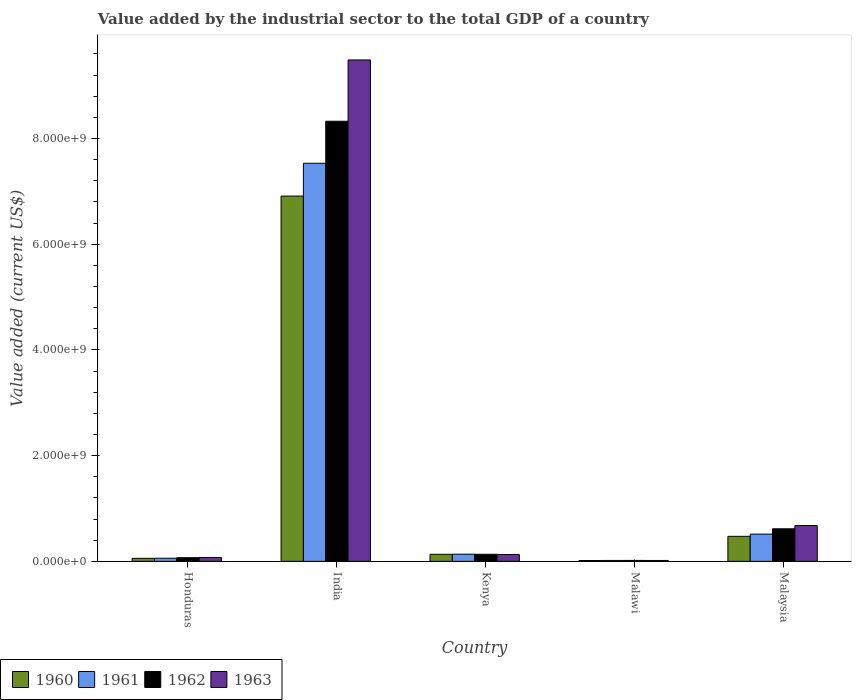How many groups of bars are there?
Offer a terse response. 5. Are the number of bars on each tick of the X-axis equal?
Your answer should be compact. Yes. How many bars are there on the 5th tick from the left?
Keep it short and to the point. 4. How many bars are there on the 5th tick from the right?
Give a very brief answer. 4. What is the value added by the industrial sector to the total GDP in 1963 in Honduras?
Offer a very short reply. 7.38e+07. Across all countries, what is the maximum value added by the industrial sector to the total GDP in 1962?
Your response must be concise. 8.33e+09. Across all countries, what is the minimum value added by the industrial sector to the total GDP in 1960?
Ensure brevity in your answer.  1.62e+07. In which country was the value added by the industrial sector to the total GDP in 1962 maximum?
Your response must be concise. India. In which country was the value added by the industrial sector to the total GDP in 1961 minimum?
Give a very brief answer. Malawi. What is the total value added by the industrial sector to the total GDP in 1961 in the graph?
Offer a terse response. 8.26e+09. What is the difference between the value added by the industrial sector to the total GDP in 1962 in Honduras and that in India?
Give a very brief answer. -8.26e+09. What is the difference between the value added by the industrial sector to the total GDP in 1963 in India and the value added by the industrial sector to the total GDP in 1962 in Malawi?
Your answer should be compact. 9.47e+09. What is the average value added by the industrial sector to the total GDP in 1960 per country?
Provide a short and direct response. 1.52e+09. What is the difference between the value added by the industrial sector to the total GDP of/in 1962 and value added by the industrial sector to the total GDP of/in 1963 in Malawi?
Your response must be concise. 8.40e+05. What is the ratio of the value added by the industrial sector to the total GDP in 1960 in Honduras to that in Kenya?
Provide a short and direct response. 0.43. Is the value added by the industrial sector to the total GDP in 1963 in India less than that in Malawi?
Your answer should be very brief. No. Is the difference between the value added by the industrial sector to the total GDP in 1962 in Honduras and Malaysia greater than the difference between the value added by the industrial sector to the total GDP in 1963 in Honduras and Malaysia?
Offer a very short reply. Yes. What is the difference between the highest and the second highest value added by the industrial sector to the total GDP in 1963?
Your answer should be very brief. 9.36e+09. What is the difference between the highest and the lowest value added by the industrial sector to the total GDP in 1962?
Give a very brief answer. 8.31e+09. Is the sum of the value added by the industrial sector to the total GDP in 1960 in India and Malawi greater than the maximum value added by the industrial sector to the total GDP in 1963 across all countries?
Give a very brief answer. No. How many countries are there in the graph?
Provide a succinct answer. 5. What is the difference between two consecutive major ticks on the Y-axis?
Your response must be concise. 2.00e+09. Does the graph contain any zero values?
Offer a very short reply. No. Where does the legend appear in the graph?
Give a very brief answer. Bottom left. How many legend labels are there?
Provide a short and direct response. 4. What is the title of the graph?
Ensure brevity in your answer.  Value added by the industrial sector to the total GDP of a country. What is the label or title of the X-axis?
Your response must be concise. Country. What is the label or title of the Y-axis?
Give a very brief answer. Value added (current US$). What is the Value added (current US$) of 1960 in Honduras?
Your response must be concise. 5.73e+07. What is the Value added (current US$) of 1961 in Honduras?
Keep it short and to the point. 5.94e+07. What is the Value added (current US$) in 1962 in Honduras?
Your answer should be compact. 6.92e+07. What is the Value added (current US$) in 1963 in Honduras?
Keep it short and to the point. 7.38e+07. What is the Value added (current US$) of 1960 in India?
Make the answer very short. 6.91e+09. What is the Value added (current US$) of 1961 in India?
Give a very brief answer. 7.53e+09. What is the Value added (current US$) in 1962 in India?
Ensure brevity in your answer.  8.33e+09. What is the Value added (current US$) of 1963 in India?
Keep it short and to the point. 9.49e+09. What is the Value added (current US$) of 1960 in Kenya?
Your answer should be very brief. 1.34e+08. What is the Value added (current US$) of 1961 in Kenya?
Your answer should be very brief. 1.36e+08. What is the Value added (current US$) in 1962 in Kenya?
Keep it short and to the point. 1.34e+08. What is the Value added (current US$) of 1963 in Kenya?
Keep it short and to the point. 1.30e+08. What is the Value added (current US$) of 1960 in Malawi?
Offer a very short reply. 1.62e+07. What is the Value added (current US$) in 1961 in Malawi?
Your answer should be very brief. 1.76e+07. What is the Value added (current US$) in 1962 in Malawi?
Make the answer very short. 1.78e+07. What is the Value added (current US$) in 1963 in Malawi?
Your answer should be very brief. 1.69e+07. What is the Value added (current US$) in 1960 in Malaysia?
Your answer should be very brief. 4.74e+08. What is the Value added (current US$) in 1961 in Malaysia?
Your answer should be compact. 5.15e+08. What is the Value added (current US$) of 1962 in Malaysia?
Your answer should be compact. 6.16e+08. What is the Value added (current US$) of 1963 in Malaysia?
Provide a succinct answer. 6.77e+08. Across all countries, what is the maximum Value added (current US$) of 1960?
Offer a terse response. 6.91e+09. Across all countries, what is the maximum Value added (current US$) in 1961?
Give a very brief answer. 7.53e+09. Across all countries, what is the maximum Value added (current US$) of 1962?
Offer a terse response. 8.33e+09. Across all countries, what is the maximum Value added (current US$) in 1963?
Give a very brief answer. 9.49e+09. Across all countries, what is the minimum Value added (current US$) of 1960?
Offer a very short reply. 1.62e+07. Across all countries, what is the minimum Value added (current US$) of 1961?
Your answer should be compact. 1.76e+07. Across all countries, what is the minimum Value added (current US$) of 1962?
Keep it short and to the point. 1.78e+07. Across all countries, what is the minimum Value added (current US$) of 1963?
Offer a very short reply. 1.69e+07. What is the total Value added (current US$) of 1960 in the graph?
Provide a short and direct response. 7.59e+09. What is the total Value added (current US$) in 1961 in the graph?
Your response must be concise. 8.26e+09. What is the total Value added (current US$) in 1962 in the graph?
Ensure brevity in your answer.  9.16e+09. What is the total Value added (current US$) of 1963 in the graph?
Give a very brief answer. 1.04e+1. What is the difference between the Value added (current US$) of 1960 in Honduras and that in India?
Your answer should be very brief. -6.85e+09. What is the difference between the Value added (current US$) of 1961 in Honduras and that in India?
Offer a terse response. -7.47e+09. What is the difference between the Value added (current US$) of 1962 in Honduras and that in India?
Offer a terse response. -8.26e+09. What is the difference between the Value added (current US$) in 1963 in Honduras and that in India?
Keep it short and to the point. -9.41e+09. What is the difference between the Value added (current US$) of 1960 in Honduras and that in Kenya?
Offer a terse response. -7.63e+07. What is the difference between the Value added (current US$) of 1961 in Honduras and that in Kenya?
Offer a very short reply. -7.65e+07. What is the difference between the Value added (current US$) of 1962 in Honduras and that in Kenya?
Your answer should be very brief. -6.47e+07. What is the difference between the Value added (current US$) in 1963 in Honduras and that in Kenya?
Offer a terse response. -5.57e+07. What is the difference between the Value added (current US$) in 1960 in Honduras and that in Malawi?
Give a very brief answer. 4.11e+07. What is the difference between the Value added (current US$) in 1961 in Honduras and that in Malawi?
Your answer should be compact. 4.17e+07. What is the difference between the Value added (current US$) in 1962 in Honduras and that in Malawi?
Offer a very short reply. 5.14e+07. What is the difference between the Value added (current US$) in 1963 in Honduras and that in Malawi?
Give a very brief answer. 5.69e+07. What is the difference between the Value added (current US$) of 1960 in Honduras and that in Malaysia?
Provide a succinct answer. -4.16e+08. What is the difference between the Value added (current US$) of 1961 in Honduras and that in Malaysia?
Your answer should be compact. -4.56e+08. What is the difference between the Value added (current US$) of 1962 in Honduras and that in Malaysia?
Offer a terse response. -5.47e+08. What is the difference between the Value added (current US$) of 1963 in Honduras and that in Malaysia?
Make the answer very short. -6.04e+08. What is the difference between the Value added (current US$) in 1960 in India and that in Kenya?
Your answer should be very brief. 6.78e+09. What is the difference between the Value added (current US$) of 1961 in India and that in Kenya?
Give a very brief answer. 7.40e+09. What is the difference between the Value added (current US$) in 1962 in India and that in Kenya?
Offer a very short reply. 8.19e+09. What is the difference between the Value added (current US$) of 1963 in India and that in Kenya?
Your response must be concise. 9.36e+09. What is the difference between the Value added (current US$) in 1960 in India and that in Malawi?
Make the answer very short. 6.89e+09. What is the difference between the Value added (current US$) in 1961 in India and that in Malawi?
Keep it short and to the point. 7.51e+09. What is the difference between the Value added (current US$) in 1962 in India and that in Malawi?
Provide a short and direct response. 8.31e+09. What is the difference between the Value added (current US$) of 1963 in India and that in Malawi?
Provide a succinct answer. 9.47e+09. What is the difference between the Value added (current US$) of 1960 in India and that in Malaysia?
Keep it short and to the point. 6.44e+09. What is the difference between the Value added (current US$) of 1961 in India and that in Malaysia?
Offer a very short reply. 7.02e+09. What is the difference between the Value added (current US$) in 1962 in India and that in Malaysia?
Your answer should be compact. 7.71e+09. What is the difference between the Value added (current US$) of 1963 in India and that in Malaysia?
Make the answer very short. 8.81e+09. What is the difference between the Value added (current US$) in 1960 in Kenya and that in Malawi?
Keep it short and to the point. 1.17e+08. What is the difference between the Value added (current US$) in 1961 in Kenya and that in Malawi?
Keep it short and to the point. 1.18e+08. What is the difference between the Value added (current US$) of 1962 in Kenya and that in Malawi?
Provide a succinct answer. 1.16e+08. What is the difference between the Value added (current US$) of 1963 in Kenya and that in Malawi?
Your response must be concise. 1.13e+08. What is the difference between the Value added (current US$) in 1960 in Kenya and that in Malaysia?
Your answer should be very brief. -3.40e+08. What is the difference between the Value added (current US$) of 1961 in Kenya and that in Malaysia?
Your response must be concise. -3.79e+08. What is the difference between the Value added (current US$) in 1962 in Kenya and that in Malaysia?
Offer a terse response. -4.82e+08. What is the difference between the Value added (current US$) in 1963 in Kenya and that in Malaysia?
Offer a very short reply. -5.48e+08. What is the difference between the Value added (current US$) in 1960 in Malawi and that in Malaysia?
Your response must be concise. -4.57e+08. What is the difference between the Value added (current US$) in 1961 in Malawi and that in Malaysia?
Your response must be concise. -4.98e+08. What is the difference between the Value added (current US$) of 1962 in Malawi and that in Malaysia?
Your response must be concise. -5.98e+08. What is the difference between the Value added (current US$) of 1963 in Malawi and that in Malaysia?
Your answer should be very brief. -6.61e+08. What is the difference between the Value added (current US$) in 1960 in Honduras and the Value added (current US$) in 1961 in India?
Offer a terse response. -7.47e+09. What is the difference between the Value added (current US$) in 1960 in Honduras and the Value added (current US$) in 1962 in India?
Ensure brevity in your answer.  -8.27e+09. What is the difference between the Value added (current US$) in 1960 in Honduras and the Value added (current US$) in 1963 in India?
Your response must be concise. -9.43e+09. What is the difference between the Value added (current US$) in 1961 in Honduras and the Value added (current US$) in 1962 in India?
Keep it short and to the point. -8.27e+09. What is the difference between the Value added (current US$) in 1961 in Honduras and the Value added (current US$) in 1963 in India?
Your answer should be compact. -9.43e+09. What is the difference between the Value added (current US$) of 1962 in Honduras and the Value added (current US$) of 1963 in India?
Provide a short and direct response. -9.42e+09. What is the difference between the Value added (current US$) of 1960 in Honduras and the Value added (current US$) of 1961 in Kenya?
Provide a short and direct response. -7.86e+07. What is the difference between the Value added (current US$) in 1960 in Honduras and the Value added (current US$) in 1962 in Kenya?
Provide a short and direct response. -7.66e+07. What is the difference between the Value added (current US$) in 1960 in Honduras and the Value added (current US$) in 1963 in Kenya?
Your response must be concise. -7.22e+07. What is the difference between the Value added (current US$) of 1961 in Honduras and the Value added (current US$) of 1962 in Kenya?
Offer a terse response. -7.46e+07. What is the difference between the Value added (current US$) in 1961 in Honduras and the Value added (current US$) in 1963 in Kenya?
Your response must be concise. -7.02e+07. What is the difference between the Value added (current US$) in 1962 in Honduras and the Value added (current US$) in 1963 in Kenya?
Offer a very short reply. -6.03e+07. What is the difference between the Value added (current US$) of 1960 in Honduras and the Value added (current US$) of 1961 in Malawi?
Ensure brevity in your answer.  3.97e+07. What is the difference between the Value added (current US$) in 1960 in Honduras and the Value added (current US$) in 1962 in Malawi?
Provide a short and direct response. 3.95e+07. What is the difference between the Value added (current US$) in 1960 in Honduras and the Value added (current US$) in 1963 in Malawi?
Your answer should be very brief. 4.04e+07. What is the difference between the Value added (current US$) in 1961 in Honduras and the Value added (current US$) in 1962 in Malawi?
Offer a terse response. 4.16e+07. What is the difference between the Value added (current US$) of 1961 in Honduras and the Value added (current US$) of 1963 in Malawi?
Your answer should be compact. 4.24e+07. What is the difference between the Value added (current US$) in 1962 in Honduras and the Value added (current US$) in 1963 in Malawi?
Your response must be concise. 5.23e+07. What is the difference between the Value added (current US$) of 1960 in Honduras and the Value added (current US$) of 1961 in Malaysia?
Ensure brevity in your answer.  -4.58e+08. What is the difference between the Value added (current US$) in 1960 in Honduras and the Value added (current US$) in 1962 in Malaysia?
Your response must be concise. -5.59e+08. What is the difference between the Value added (current US$) of 1960 in Honduras and the Value added (current US$) of 1963 in Malaysia?
Provide a short and direct response. -6.20e+08. What is the difference between the Value added (current US$) in 1961 in Honduras and the Value added (current US$) in 1962 in Malaysia?
Ensure brevity in your answer.  -5.57e+08. What is the difference between the Value added (current US$) in 1961 in Honduras and the Value added (current US$) in 1963 in Malaysia?
Offer a terse response. -6.18e+08. What is the difference between the Value added (current US$) in 1962 in Honduras and the Value added (current US$) in 1963 in Malaysia?
Give a very brief answer. -6.08e+08. What is the difference between the Value added (current US$) of 1960 in India and the Value added (current US$) of 1961 in Kenya?
Provide a short and direct response. 6.77e+09. What is the difference between the Value added (current US$) of 1960 in India and the Value added (current US$) of 1962 in Kenya?
Provide a short and direct response. 6.78e+09. What is the difference between the Value added (current US$) of 1960 in India and the Value added (current US$) of 1963 in Kenya?
Keep it short and to the point. 6.78e+09. What is the difference between the Value added (current US$) in 1961 in India and the Value added (current US$) in 1962 in Kenya?
Your response must be concise. 7.40e+09. What is the difference between the Value added (current US$) of 1961 in India and the Value added (current US$) of 1963 in Kenya?
Keep it short and to the point. 7.40e+09. What is the difference between the Value added (current US$) in 1962 in India and the Value added (current US$) in 1963 in Kenya?
Make the answer very short. 8.20e+09. What is the difference between the Value added (current US$) in 1960 in India and the Value added (current US$) in 1961 in Malawi?
Make the answer very short. 6.89e+09. What is the difference between the Value added (current US$) of 1960 in India and the Value added (current US$) of 1962 in Malawi?
Provide a succinct answer. 6.89e+09. What is the difference between the Value added (current US$) in 1960 in India and the Value added (current US$) in 1963 in Malawi?
Give a very brief answer. 6.89e+09. What is the difference between the Value added (current US$) in 1961 in India and the Value added (current US$) in 1962 in Malawi?
Offer a very short reply. 7.51e+09. What is the difference between the Value added (current US$) of 1961 in India and the Value added (current US$) of 1963 in Malawi?
Your response must be concise. 7.51e+09. What is the difference between the Value added (current US$) of 1962 in India and the Value added (current US$) of 1963 in Malawi?
Keep it short and to the point. 8.31e+09. What is the difference between the Value added (current US$) of 1960 in India and the Value added (current US$) of 1961 in Malaysia?
Provide a succinct answer. 6.39e+09. What is the difference between the Value added (current US$) in 1960 in India and the Value added (current US$) in 1962 in Malaysia?
Offer a very short reply. 6.29e+09. What is the difference between the Value added (current US$) of 1960 in India and the Value added (current US$) of 1963 in Malaysia?
Offer a very short reply. 6.23e+09. What is the difference between the Value added (current US$) of 1961 in India and the Value added (current US$) of 1962 in Malaysia?
Ensure brevity in your answer.  6.92e+09. What is the difference between the Value added (current US$) in 1961 in India and the Value added (current US$) in 1963 in Malaysia?
Keep it short and to the point. 6.85e+09. What is the difference between the Value added (current US$) of 1962 in India and the Value added (current US$) of 1963 in Malaysia?
Provide a succinct answer. 7.65e+09. What is the difference between the Value added (current US$) in 1960 in Kenya and the Value added (current US$) in 1961 in Malawi?
Offer a very short reply. 1.16e+08. What is the difference between the Value added (current US$) of 1960 in Kenya and the Value added (current US$) of 1962 in Malawi?
Offer a terse response. 1.16e+08. What is the difference between the Value added (current US$) in 1960 in Kenya and the Value added (current US$) in 1963 in Malawi?
Offer a very short reply. 1.17e+08. What is the difference between the Value added (current US$) of 1961 in Kenya and the Value added (current US$) of 1962 in Malawi?
Provide a short and direct response. 1.18e+08. What is the difference between the Value added (current US$) in 1961 in Kenya and the Value added (current US$) in 1963 in Malawi?
Your answer should be compact. 1.19e+08. What is the difference between the Value added (current US$) of 1962 in Kenya and the Value added (current US$) of 1963 in Malawi?
Ensure brevity in your answer.  1.17e+08. What is the difference between the Value added (current US$) of 1960 in Kenya and the Value added (current US$) of 1961 in Malaysia?
Your answer should be compact. -3.82e+08. What is the difference between the Value added (current US$) in 1960 in Kenya and the Value added (current US$) in 1962 in Malaysia?
Provide a short and direct response. -4.82e+08. What is the difference between the Value added (current US$) of 1960 in Kenya and the Value added (current US$) of 1963 in Malaysia?
Your answer should be compact. -5.44e+08. What is the difference between the Value added (current US$) of 1961 in Kenya and the Value added (current US$) of 1962 in Malaysia?
Provide a succinct answer. -4.80e+08. What is the difference between the Value added (current US$) in 1961 in Kenya and the Value added (current US$) in 1963 in Malaysia?
Your answer should be compact. -5.42e+08. What is the difference between the Value added (current US$) in 1962 in Kenya and the Value added (current US$) in 1963 in Malaysia?
Provide a succinct answer. -5.44e+08. What is the difference between the Value added (current US$) in 1960 in Malawi and the Value added (current US$) in 1961 in Malaysia?
Offer a very short reply. -4.99e+08. What is the difference between the Value added (current US$) of 1960 in Malawi and the Value added (current US$) of 1962 in Malaysia?
Provide a short and direct response. -6.00e+08. What is the difference between the Value added (current US$) in 1960 in Malawi and the Value added (current US$) in 1963 in Malaysia?
Ensure brevity in your answer.  -6.61e+08. What is the difference between the Value added (current US$) of 1961 in Malawi and the Value added (current US$) of 1962 in Malaysia?
Provide a short and direct response. -5.98e+08. What is the difference between the Value added (current US$) in 1961 in Malawi and the Value added (current US$) in 1963 in Malaysia?
Offer a terse response. -6.60e+08. What is the difference between the Value added (current US$) of 1962 in Malawi and the Value added (current US$) of 1963 in Malaysia?
Your answer should be very brief. -6.60e+08. What is the average Value added (current US$) in 1960 per country?
Your response must be concise. 1.52e+09. What is the average Value added (current US$) of 1961 per country?
Provide a succinct answer. 1.65e+09. What is the average Value added (current US$) in 1962 per country?
Your answer should be very brief. 1.83e+09. What is the average Value added (current US$) of 1963 per country?
Ensure brevity in your answer.  2.08e+09. What is the difference between the Value added (current US$) of 1960 and Value added (current US$) of 1961 in Honduras?
Ensure brevity in your answer.  -2.05e+06. What is the difference between the Value added (current US$) in 1960 and Value added (current US$) in 1962 in Honduras?
Make the answer very short. -1.19e+07. What is the difference between the Value added (current US$) in 1960 and Value added (current US$) in 1963 in Honduras?
Your answer should be compact. -1.65e+07. What is the difference between the Value added (current US$) in 1961 and Value added (current US$) in 1962 in Honduras?
Provide a succinct answer. -9.85e+06. What is the difference between the Value added (current US$) in 1961 and Value added (current US$) in 1963 in Honduras?
Provide a succinct answer. -1.44e+07. What is the difference between the Value added (current US$) in 1962 and Value added (current US$) in 1963 in Honduras?
Your answer should be compact. -4.60e+06. What is the difference between the Value added (current US$) of 1960 and Value added (current US$) of 1961 in India?
Your answer should be very brief. -6.21e+08. What is the difference between the Value added (current US$) in 1960 and Value added (current US$) in 1962 in India?
Your answer should be compact. -1.42e+09. What is the difference between the Value added (current US$) in 1960 and Value added (current US$) in 1963 in India?
Provide a succinct answer. -2.58e+09. What is the difference between the Value added (current US$) of 1961 and Value added (current US$) of 1962 in India?
Offer a very short reply. -7.94e+08. What is the difference between the Value added (current US$) in 1961 and Value added (current US$) in 1963 in India?
Provide a short and direct response. -1.95e+09. What is the difference between the Value added (current US$) of 1962 and Value added (current US$) of 1963 in India?
Your response must be concise. -1.16e+09. What is the difference between the Value added (current US$) of 1960 and Value added (current US$) of 1961 in Kenya?
Your answer should be very brief. -2.25e+06. What is the difference between the Value added (current US$) in 1960 and Value added (current US$) in 1962 in Kenya?
Provide a short and direct response. -2.94e+05. What is the difference between the Value added (current US$) of 1960 and Value added (current US$) of 1963 in Kenya?
Keep it short and to the point. 4.12e+06. What is the difference between the Value added (current US$) in 1961 and Value added (current US$) in 1962 in Kenya?
Your answer should be very brief. 1.96e+06. What is the difference between the Value added (current US$) of 1961 and Value added (current US$) of 1963 in Kenya?
Provide a succinct answer. 6.37e+06. What is the difference between the Value added (current US$) of 1962 and Value added (current US$) of 1963 in Kenya?
Offer a very short reply. 4.41e+06. What is the difference between the Value added (current US$) of 1960 and Value added (current US$) of 1961 in Malawi?
Make the answer very short. -1.40e+06. What is the difference between the Value added (current US$) of 1960 and Value added (current US$) of 1962 in Malawi?
Your answer should be very brief. -1.54e+06. What is the difference between the Value added (current US$) of 1960 and Value added (current US$) of 1963 in Malawi?
Your response must be concise. -7.00e+05. What is the difference between the Value added (current US$) in 1961 and Value added (current US$) in 1962 in Malawi?
Your response must be concise. -1.40e+05. What is the difference between the Value added (current US$) in 1961 and Value added (current US$) in 1963 in Malawi?
Provide a short and direct response. 7.00e+05. What is the difference between the Value added (current US$) of 1962 and Value added (current US$) of 1963 in Malawi?
Provide a succinct answer. 8.40e+05. What is the difference between the Value added (current US$) of 1960 and Value added (current US$) of 1961 in Malaysia?
Provide a short and direct response. -4.19e+07. What is the difference between the Value added (current US$) of 1960 and Value added (current US$) of 1962 in Malaysia?
Offer a very short reply. -1.43e+08. What is the difference between the Value added (current US$) in 1960 and Value added (current US$) in 1963 in Malaysia?
Your answer should be very brief. -2.04e+08. What is the difference between the Value added (current US$) of 1961 and Value added (current US$) of 1962 in Malaysia?
Give a very brief answer. -1.01e+08. What is the difference between the Value added (current US$) in 1961 and Value added (current US$) in 1963 in Malaysia?
Provide a short and direct response. -1.62e+08. What is the difference between the Value added (current US$) in 1962 and Value added (current US$) in 1963 in Malaysia?
Make the answer very short. -6.14e+07. What is the ratio of the Value added (current US$) in 1960 in Honduras to that in India?
Your answer should be compact. 0.01. What is the ratio of the Value added (current US$) in 1961 in Honduras to that in India?
Your response must be concise. 0.01. What is the ratio of the Value added (current US$) in 1962 in Honduras to that in India?
Make the answer very short. 0.01. What is the ratio of the Value added (current US$) in 1963 in Honduras to that in India?
Give a very brief answer. 0.01. What is the ratio of the Value added (current US$) in 1960 in Honduras to that in Kenya?
Give a very brief answer. 0.43. What is the ratio of the Value added (current US$) of 1961 in Honduras to that in Kenya?
Your answer should be very brief. 0.44. What is the ratio of the Value added (current US$) in 1962 in Honduras to that in Kenya?
Offer a terse response. 0.52. What is the ratio of the Value added (current US$) in 1963 in Honduras to that in Kenya?
Provide a succinct answer. 0.57. What is the ratio of the Value added (current US$) of 1960 in Honduras to that in Malawi?
Your response must be concise. 3.53. What is the ratio of the Value added (current US$) in 1961 in Honduras to that in Malawi?
Provide a short and direct response. 3.36. What is the ratio of the Value added (current US$) in 1962 in Honduras to that in Malawi?
Offer a terse response. 3.89. What is the ratio of the Value added (current US$) in 1963 in Honduras to that in Malawi?
Offer a very short reply. 4.36. What is the ratio of the Value added (current US$) of 1960 in Honduras to that in Malaysia?
Give a very brief answer. 0.12. What is the ratio of the Value added (current US$) of 1961 in Honduras to that in Malaysia?
Provide a succinct answer. 0.12. What is the ratio of the Value added (current US$) in 1962 in Honduras to that in Malaysia?
Ensure brevity in your answer.  0.11. What is the ratio of the Value added (current US$) of 1963 in Honduras to that in Malaysia?
Provide a short and direct response. 0.11. What is the ratio of the Value added (current US$) in 1960 in India to that in Kenya?
Provide a short and direct response. 51.7. What is the ratio of the Value added (current US$) in 1961 in India to that in Kenya?
Your answer should be very brief. 55.42. What is the ratio of the Value added (current US$) of 1962 in India to that in Kenya?
Provide a succinct answer. 62.16. What is the ratio of the Value added (current US$) in 1963 in India to that in Kenya?
Your response must be concise. 73.23. What is the ratio of the Value added (current US$) in 1960 in India to that in Malawi?
Your answer should be very brief. 425.49. What is the ratio of the Value added (current US$) in 1961 in India to that in Malawi?
Keep it short and to the point. 426.94. What is the ratio of the Value added (current US$) in 1962 in India to that in Malawi?
Ensure brevity in your answer.  468.26. What is the ratio of the Value added (current US$) in 1963 in India to that in Malawi?
Give a very brief answer. 559.94. What is the ratio of the Value added (current US$) in 1960 in India to that in Malaysia?
Make the answer very short. 14.59. What is the ratio of the Value added (current US$) in 1961 in India to that in Malaysia?
Make the answer very short. 14.61. What is the ratio of the Value added (current US$) of 1962 in India to that in Malaysia?
Your response must be concise. 13.51. What is the ratio of the Value added (current US$) of 1963 in India to that in Malaysia?
Your answer should be very brief. 14. What is the ratio of the Value added (current US$) in 1960 in Kenya to that in Malawi?
Provide a short and direct response. 8.23. What is the ratio of the Value added (current US$) of 1961 in Kenya to that in Malawi?
Keep it short and to the point. 7.7. What is the ratio of the Value added (current US$) of 1962 in Kenya to that in Malawi?
Ensure brevity in your answer.  7.53. What is the ratio of the Value added (current US$) of 1963 in Kenya to that in Malawi?
Make the answer very short. 7.65. What is the ratio of the Value added (current US$) of 1960 in Kenya to that in Malaysia?
Your answer should be very brief. 0.28. What is the ratio of the Value added (current US$) in 1961 in Kenya to that in Malaysia?
Ensure brevity in your answer.  0.26. What is the ratio of the Value added (current US$) in 1962 in Kenya to that in Malaysia?
Offer a very short reply. 0.22. What is the ratio of the Value added (current US$) of 1963 in Kenya to that in Malaysia?
Keep it short and to the point. 0.19. What is the ratio of the Value added (current US$) in 1960 in Malawi to that in Malaysia?
Ensure brevity in your answer.  0.03. What is the ratio of the Value added (current US$) in 1961 in Malawi to that in Malaysia?
Your response must be concise. 0.03. What is the ratio of the Value added (current US$) of 1962 in Malawi to that in Malaysia?
Your response must be concise. 0.03. What is the ratio of the Value added (current US$) of 1963 in Malawi to that in Malaysia?
Your response must be concise. 0.03. What is the difference between the highest and the second highest Value added (current US$) of 1960?
Offer a terse response. 6.44e+09. What is the difference between the highest and the second highest Value added (current US$) in 1961?
Give a very brief answer. 7.02e+09. What is the difference between the highest and the second highest Value added (current US$) of 1962?
Provide a short and direct response. 7.71e+09. What is the difference between the highest and the second highest Value added (current US$) in 1963?
Ensure brevity in your answer.  8.81e+09. What is the difference between the highest and the lowest Value added (current US$) of 1960?
Your answer should be compact. 6.89e+09. What is the difference between the highest and the lowest Value added (current US$) in 1961?
Offer a very short reply. 7.51e+09. What is the difference between the highest and the lowest Value added (current US$) of 1962?
Make the answer very short. 8.31e+09. What is the difference between the highest and the lowest Value added (current US$) in 1963?
Your answer should be very brief. 9.47e+09. 